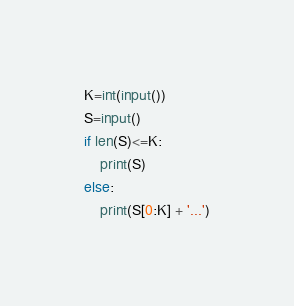<code> <loc_0><loc_0><loc_500><loc_500><_Python_>K=int(input())
S=input()
if len(S)<=K:
    print(S)
else:
    print(S[0:K] + '...')</code> 